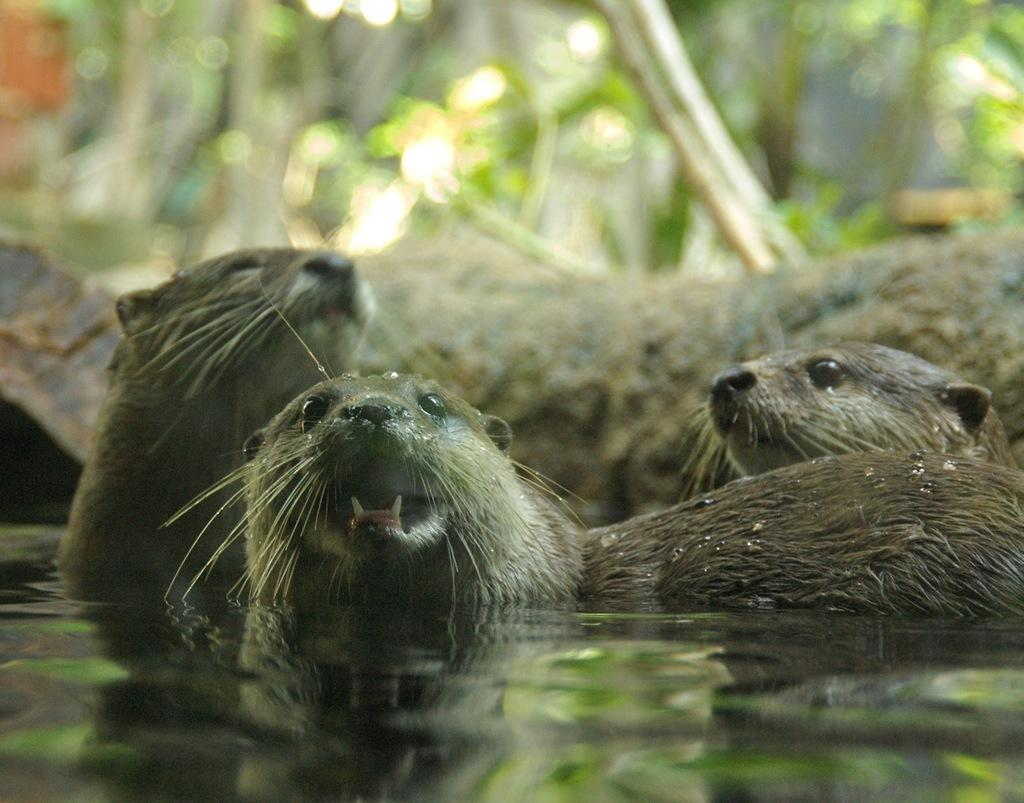What type of animals can be seen in the image? There are seals in the water. What can be seen in the background of the image? There are trees visible in the background. What type of trade is being conducted in the image? There is no indication of any trade in the image; it features seals in the water and trees in the background. What is the seals' lunch in the image? There is no lunch visible in the image, as it only shows seals in the water and trees in the background. 